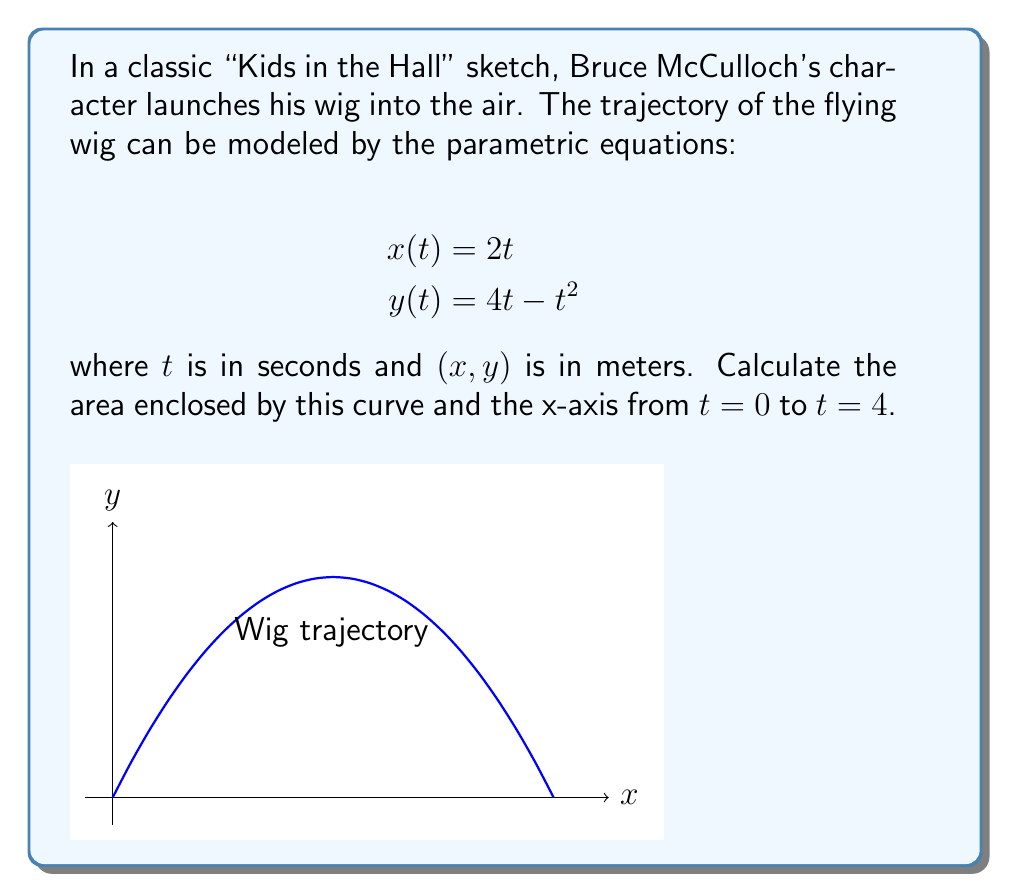Give your solution to this math problem. To find the area enclosed by the parametric curve and the x-axis, we can use the formula:

$$A = \int_{a}^{b} y(t) \frac{dx}{dt} dt$$

Where $a$ and $b$ are the start and end values of $t$.

Steps:
1) First, we need to find $\frac{dx}{dt}$:
   $$\frac{dx}{dt} = 2$$

2) Substitute this and $y(t)$ into the formula:
   $$A = \int_{0}^{4} (4t - t^2) \cdot 2 \, dt$$

3) Simplify:
   $$A = 2 \int_{0}^{4} (4t - t^2) \, dt$$

4) Integrate:
   $$A = 2 \left[ 2t^2 - \frac{1}{3}t^3 \right]_{0}^{4}$$

5) Evaluate the integral:
   $$A = 2 \left[ (2 \cdot 4^2 - \frac{1}{3} \cdot 4^3) - (2 \cdot 0^2 - \frac{1}{3} \cdot 0^3) \right]$$
   $$A = 2 \left[ (32 - \frac{64}{3}) - 0 \right]$$
   $$A = 2 \left[ \frac{32}{3} \right] = \frac{64}{3}$$

Therefore, the area enclosed by the curve and the x-axis is $\frac{64}{3}$ square meters.
Answer: $\frac{64}{3}$ m² 